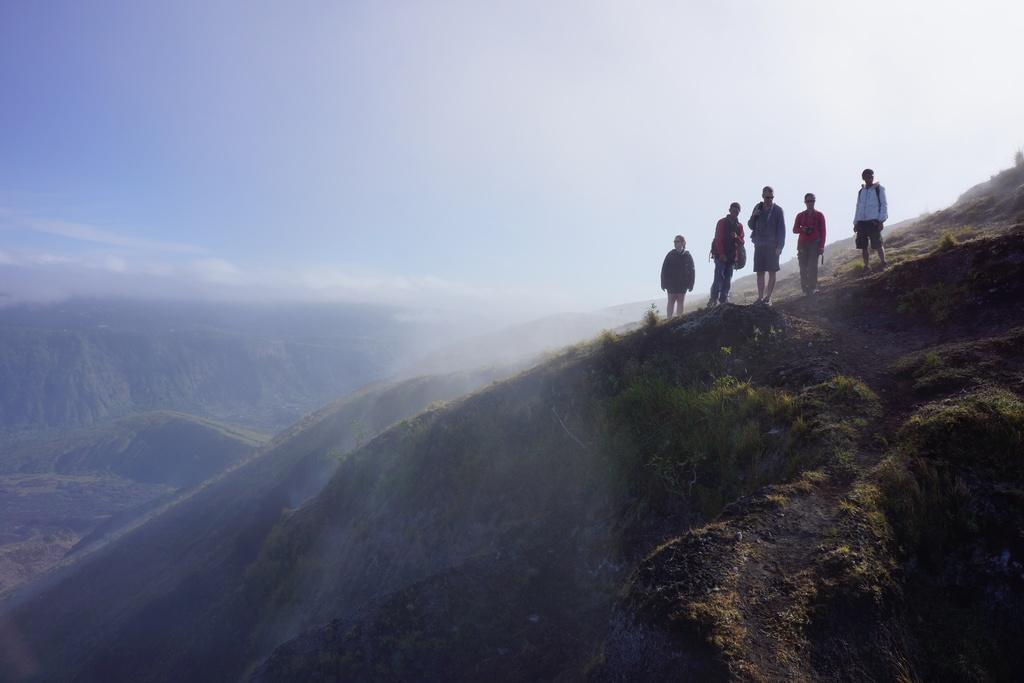How many persons are in the image? There are persons in the image, but the exact number is not specified. Where are the persons located in the image? The persons are on a hill in the image. What can be seen in the background of the image? Hills and the sky are visible in the background of the image. What is the condition of the sky in the image? Clouds are present in the sky, which suggests a partly cloudy or overcast day. What type of cracker is being used to feed the cattle in the image? There is no mention of crackers or cattle in the image; it features persons on a hill with hills and clouds visible in the background. 